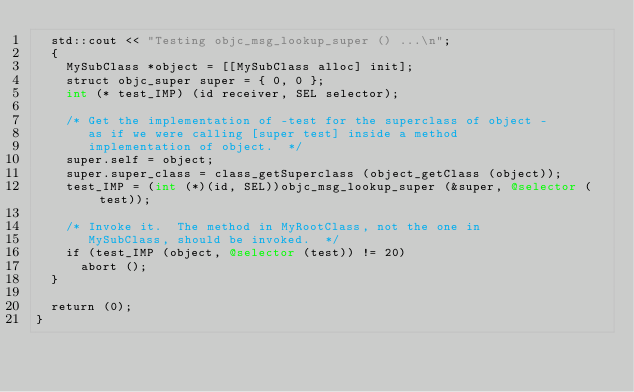<code> <loc_0><loc_0><loc_500><loc_500><_ObjectiveC_>  std::cout << "Testing objc_msg_lookup_super () ...\n";
  {
    MySubClass *object = [[MySubClass alloc] init];
    struct objc_super super = { 0, 0 };
    int (* test_IMP) (id receiver, SEL selector);

    /* Get the implementation of -test for the superclass of object -
       as if we were calling [super test] inside a method
       implementation of object.  */
    super.self = object;
    super.super_class = class_getSuperclass (object_getClass (object));
    test_IMP = (int (*)(id, SEL))objc_msg_lookup_super (&super, @selector (test));

    /* Invoke it.  The method in MyRootClass, not the one in
       MySubClass, should be invoked.  */
    if (test_IMP (object, @selector (test)) != 20)
      abort ();
  }

  return (0);
}
</code> 